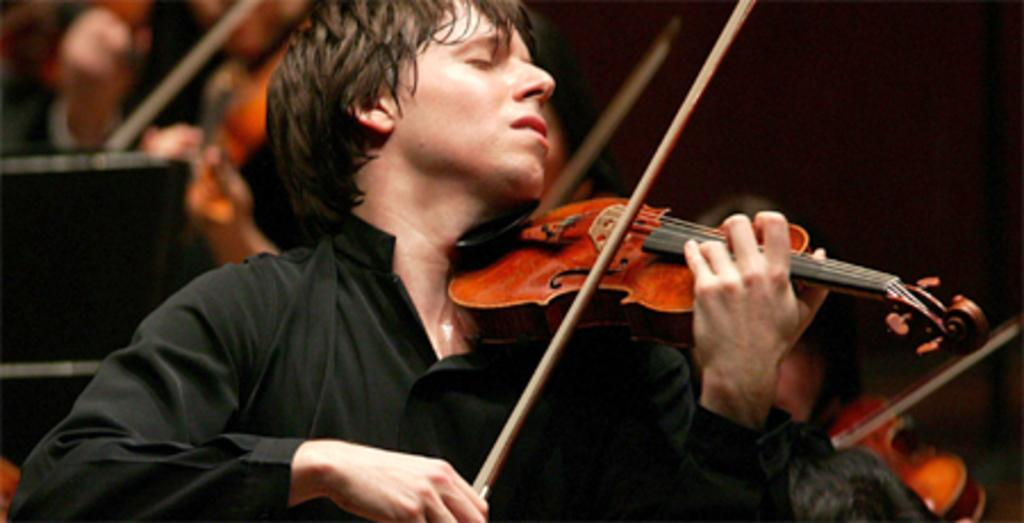What is the man in the image doing? The man in the image is playing a violin. How is the man playing the violin? The man is using his hand to play the violin. Can you describe the background of the image? There are other people in the background of the image, and they are also playing violins. What type of acoustics can be heard from the doll in the image? There is no doll present in the image, so it is not possible to determine the acoustics of a doll. 